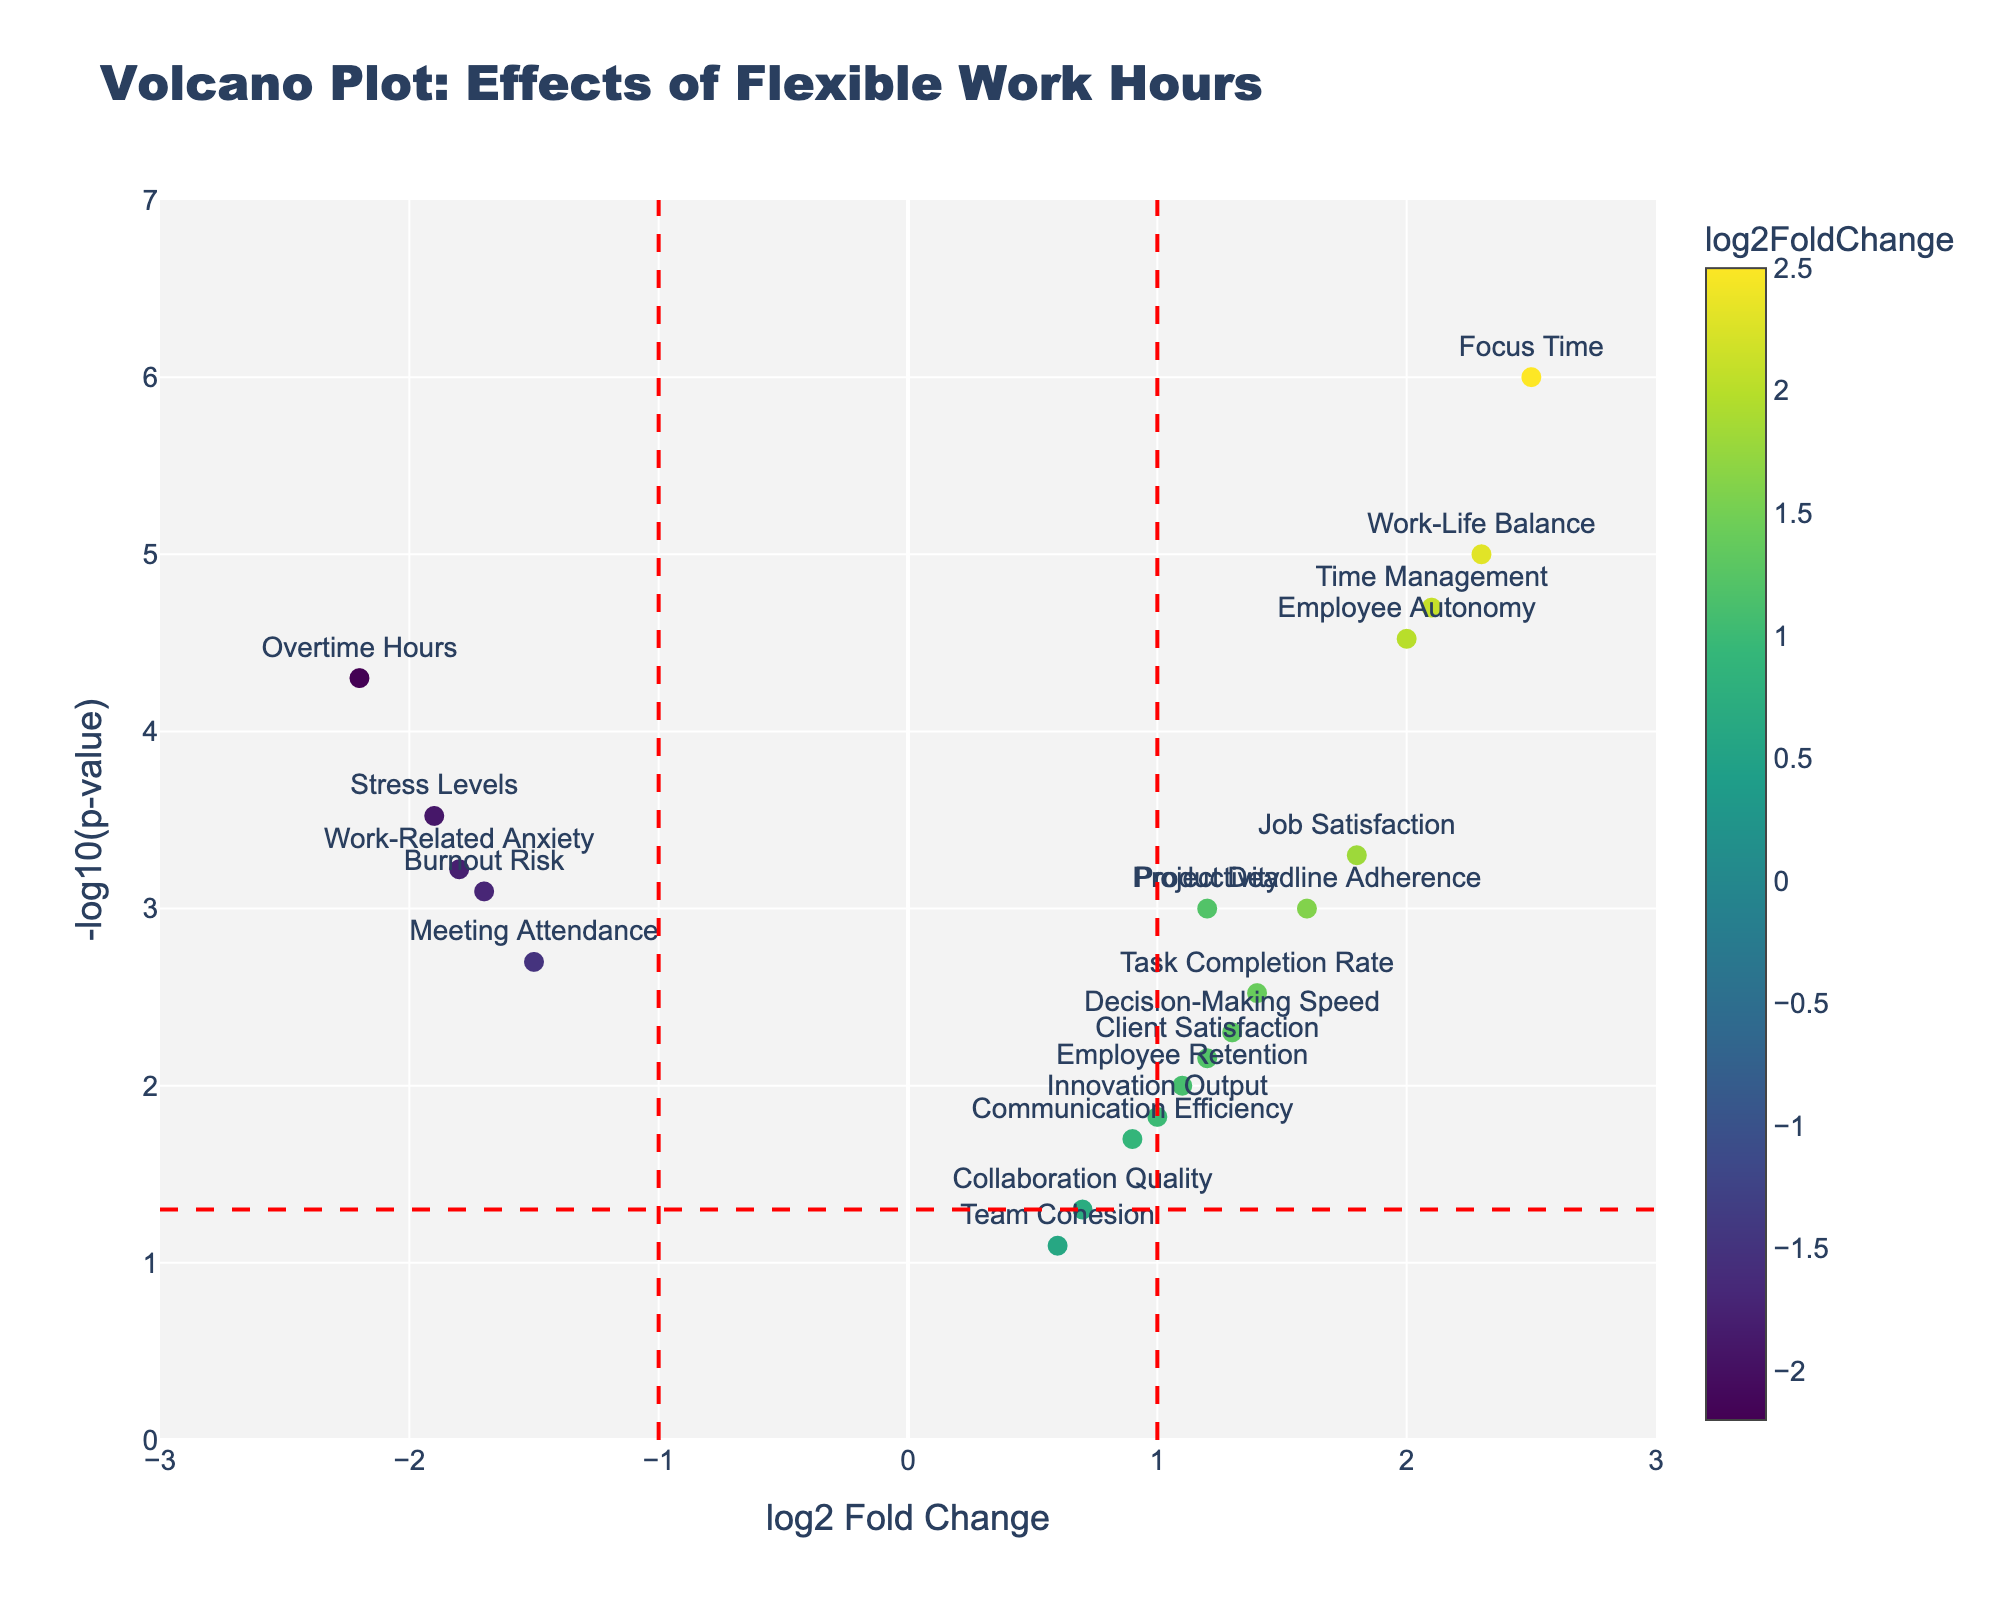what is the title of this plot? The title is usually located at the top center of the plot and is designed to provide a brief description of the main focus or subject of the plot.
Answer: Volcano Plot: Effects of Flexible Work Hours How many data points are represented in the plot? The scatter plot contains individual markers for each data point, and by counting these markers, you can determine the total number of data points. There are 20 highlighted data points in the figure.
Answer: 20 What's the highest log2FoldChange value, and which gene does it correspond to? The highest log2FoldChange is the maximum value on the x-axis, and by identifying the corresponding data point, you can ascertain the related gene. The highest value is at 2.5, corresponding to "Focus Time".
Answer: 2.5, Focus Time Which genes have a negative log2FoldChange value greater than 1? To identify these genes, look for markers on the left side of the plot where the x-axis values are less than -1. These genes are "Meeting Attendance", "Stress Levels", "Burnout Risk", "Overtime Hours", and "Work-Related Anxiety".
Answer: Meeting Attendance, Stress Levels, Burnout Risk, Overtime Hours, Work-Related Anxiety What threshold lines are present in the plot and what do they signify? The plot includes vertical lines at log2FoldChange = -1 and 1, and a horizontal line at -log10(p-value) of 0.05. The vertical lines typically demarcate significant fold changes, while the horizontal line indicates statistical significance at a p-value threshold of 0.05.
Answer: Vertical lines: -1 and 1 log2FoldChange, Horizontal line: -log10(p-value) of 0.05 Which data points fall in the top right quadrant of the plot and what does this quadrant represent? The top right quadrant has markers with positive log2FoldChange and high -log10(p-value), indicating significant positive effects with high statistical significance. These points include "Work-Life Balance", "Focus Time", "Task Completion Rate", "Job Satisfaction", "Employee Autonomy", "Project Deadline Adherence", "Time Management", and "Productivity".
Answer: Work-Life Balance, Focus Time, Task Completion Rate, Job Satisfaction, Employee Autonomy, Project Deadline Adherence, Time Management, Productivity Comparing 'Stress Levels' and 'Burnout Risk,' which one has a lower p-value? To find this, compare the -log10(p-value) of both genes; the one with the higher y-value has the lower p-value. "Stress Levels" at -1.9 log2FC has a higher y-value of 3.5228 compared to "Burnout Risk" at -1.7 log2FC with a y-value of 3.0969, meaning "Stress Levels" has a lower p-value.
Answer: Stress Levels Explain whether 'Collaboration Quality' is significantly affected by flexible work hours. First, check the gene's log2FoldChange which is 0.7 and see its position relative to the vertical significance lines. Then, consider its p-value, which translates to a -log10(p-value) when plotted. "Collaboration Quality" has a p-value of 0.05, so it's right on the significance threshold for p-value and has a log2FoldChange less than ±1, indicating it's not significantly affected.
Answer: No Which positive log2FoldChange gene has the highest p-value? Identifying the gene with the highest p-value involves looking for the smallest y-value among those with positive x-values. "Collaboration Quality" has a log2FoldChange of 0.7 and the smallest related y-value, indicating the highest p-value of 0.05 among positive fold changes.
Answer: Collaboration Quality What does it mean if a gene has a log2FoldChange less than -1 and a -log10(p-value) greater than 1.3? These genes exhibit a considerable decrease (log2FoldChange <-1) in some metric and are statistically significant (p-value < 0.05 translates to -log10(p-value) > ~1.3). Examples include "Meeting Attendance", "Stress Levels", "Burnout Risk", "Overtime Hours", and "Work-Related Anxiety," which exhibit significant declines associated with flexible work hours.
Answer: Significant decrease 